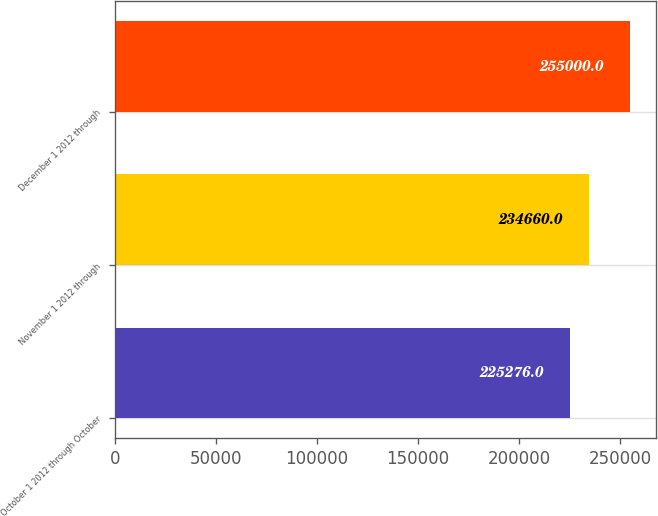Convert chart to OTSL. <chart><loc_0><loc_0><loc_500><loc_500><bar_chart><fcel>October 1 2012 through October<fcel>November 1 2012 through<fcel>December 1 2012 through<nl><fcel>225276<fcel>234660<fcel>255000<nl></chart> 